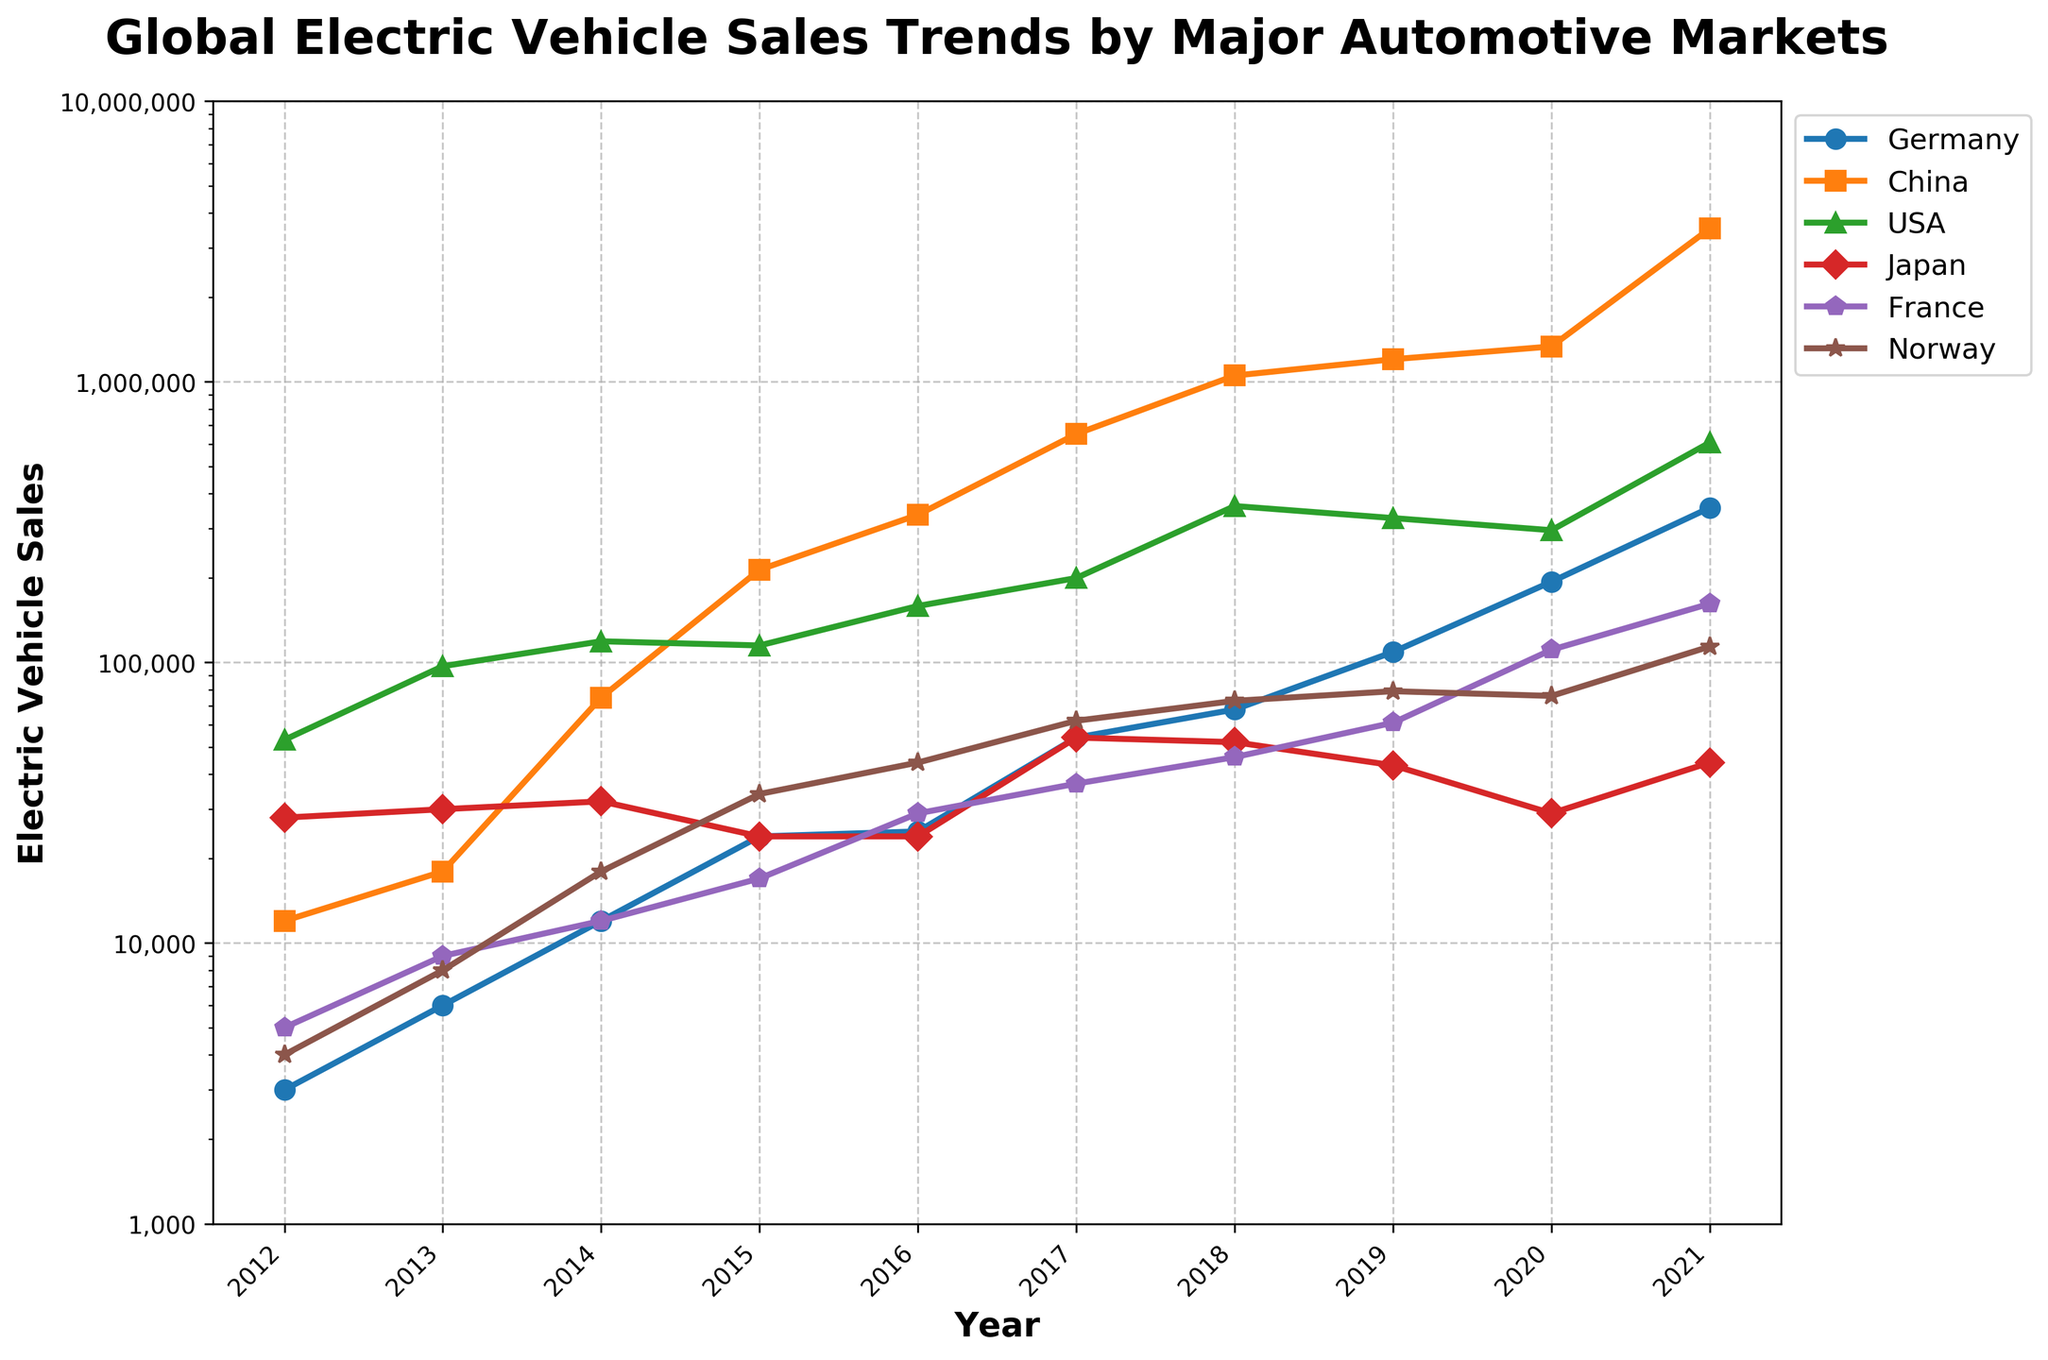What country had the highest electric vehicle sales in 2021? Looking at the plot, check all the lines at the 2021 mark and identify the one that reaches the highest point. The line for China goes the highest, indicating China had the highest electric vehicle sales in 2021.
Answer: China Which country had a faster growth in electric vehicle sales from 2012 to 2021, the USA or France? Compare the vertical distance between the start points (2012) and the endpoints (2021) of the USA and France lines. The USA line starts at 53,000 and ends at 608,000, whereas the France line starts at 5,000 and ends at 162,000. The USA had a larger increase, hence a faster growth.
Answer: USA What is the total electric vehicle sales for Germany and Norway combined in 2020? Locate the points for Germany and Norway on the 2020 mark. The sales for Germany are 194,000, and for Norway are 76,000. Add these two values together: 194,000 + 76,000 = 270,000.
Answer: 270,000 How many countries surpassed 100,000 electric vehicle sales in 2019? Check the 2019 mark for each country and count how many lines are above the 100,000 sales line. Germany (109,000), China (1,204,000), and the USA (327,000) surpassed 100,000.
Answer: 3 Between which years did China see the steepest increase in electric vehicle sales? Observe the slope of the China line between each two consecutive years from 2012 to 2021. The steepest slope is between 2020 and 2021, showing the largest increase in sales.
Answer: 2020-2021 Which country had the least number of electric vehicle sales in 2014? Identify which line is lowest at the 2014 mark. The line for Germany is the lowest, indicating it had the fewest sales.
Answer: Germany How much did Japan's electric vehicle sales decrease from 2017 to 2020? Find the sales values of Japan for the years 2017 and 2020. Sales in 2017 were 54,000 and in 2020 were 29,000. Calculate the difference: 54,000 - 29,000 = 25,000.
Answer: 25,000 What was the average electric vehicle sales for France from 2012 to 2021? Sum the sales data points for France from 2012 to 2021 (5000+9000+12000+17000+29000+37000+46000+61000+111000+162000), then divide by the number of years, which is 10. (5000+9000+12000+17000+29000+37000+46000+61000+111000+162000=505000, 505000/10=50500).
Answer: 50,500 Compare the sales trend of Norway and Japan between 2015 and 2018. Which country experienced more consistency? Check the lines for Norway and Japan from 2015 to 2018. The Japan line is relatively flat, while the Norway line shows consistent annual growth. Therefore, Japan had more consistent sales during this period.
Answer: Japan 